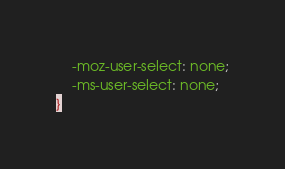Convert code to text. <code><loc_0><loc_0><loc_500><loc_500><_CSS_>	-moz-user-select: none;
	-ms-user-select: none;
}</code> 